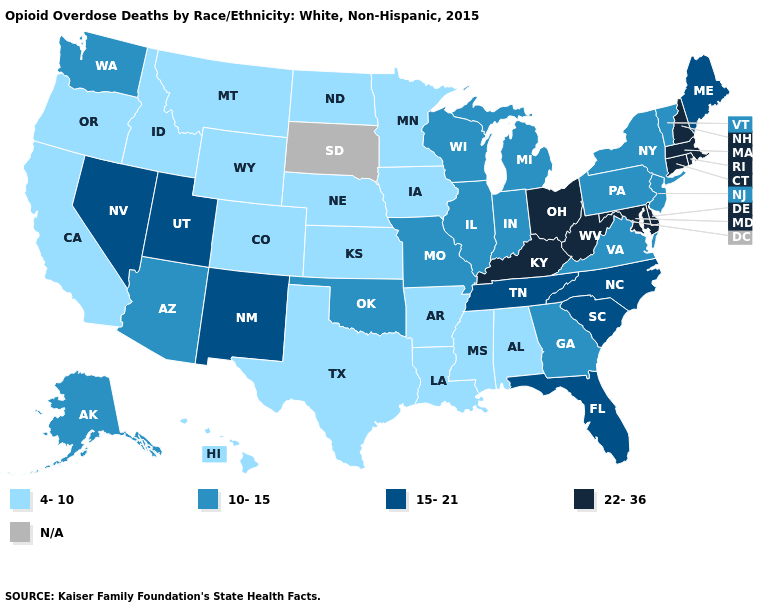Name the states that have a value in the range 4-10?
Concise answer only. Alabama, Arkansas, California, Colorado, Hawaii, Idaho, Iowa, Kansas, Louisiana, Minnesota, Mississippi, Montana, Nebraska, North Dakota, Oregon, Texas, Wyoming. Name the states that have a value in the range N/A?
Be succinct. South Dakota. Name the states that have a value in the range 22-36?
Write a very short answer. Connecticut, Delaware, Kentucky, Maryland, Massachusetts, New Hampshire, Ohio, Rhode Island, West Virginia. Name the states that have a value in the range N/A?
Give a very brief answer. South Dakota. What is the highest value in states that border Wisconsin?
Answer briefly. 10-15. Name the states that have a value in the range N/A?
Be succinct. South Dakota. Which states have the lowest value in the USA?
Be succinct. Alabama, Arkansas, California, Colorado, Hawaii, Idaho, Iowa, Kansas, Louisiana, Minnesota, Mississippi, Montana, Nebraska, North Dakota, Oregon, Texas, Wyoming. Which states have the highest value in the USA?
Write a very short answer. Connecticut, Delaware, Kentucky, Maryland, Massachusetts, New Hampshire, Ohio, Rhode Island, West Virginia. Name the states that have a value in the range 22-36?
Be succinct. Connecticut, Delaware, Kentucky, Maryland, Massachusetts, New Hampshire, Ohio, Rhode Island, West Virginia. Among the states that border Louisiana , which have the lowest value?
Answer briefly. Arkansas, Mississippi, Texas. Does Arkansas have the highest value in the South?
Write a very short answer. No. Name the states that have a value in the range 10-15?
Give a very brief answer. Alaska, Arizona, Georgia, Illinois, Indiana, Michigan, Missouri, New Jersey, New York, Oklahoma, Pennsylvania, Vermont, Virginia, Washington, Wisconsin. 